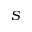<formula> <loc_0><loc_0><loc_500><loc_500>S</formula> 